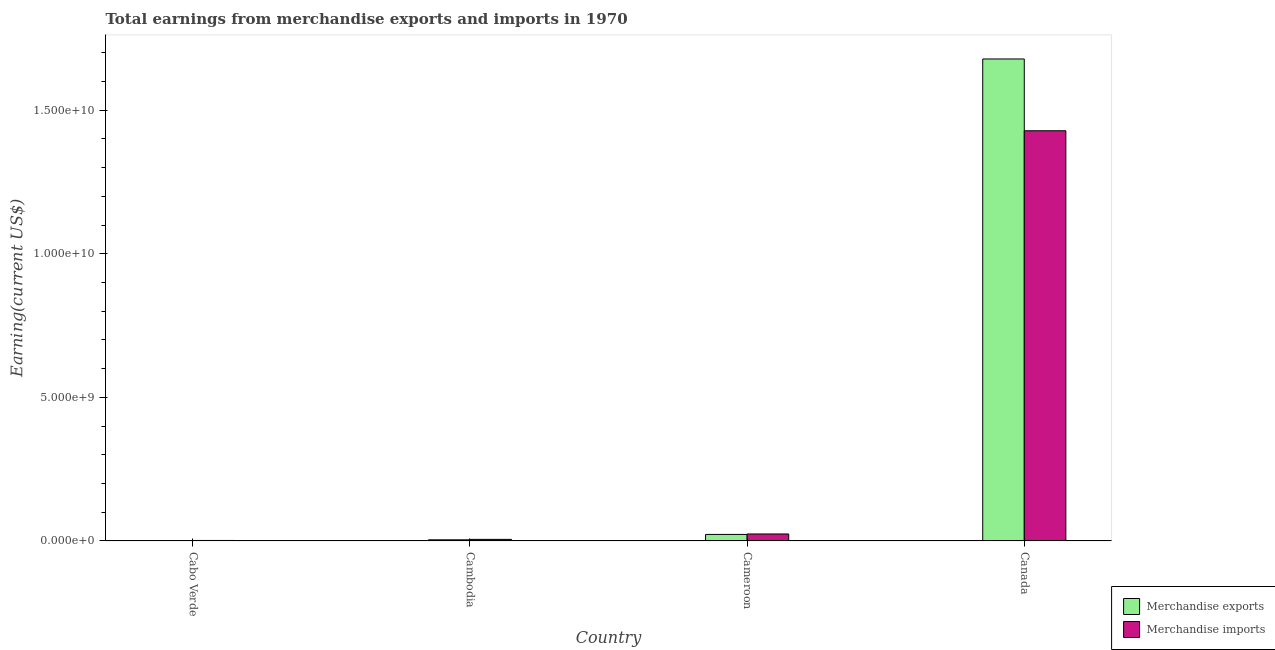How many different coloured bars are there?
Provide a succinct answer. 2. How many groups of bars are there?
Ensure brevity in your answer.  4. Are the number of bars on each tick of the X-axis equal?
Give a very brief answer. Yes. How many bars are there on the 2nd tick from the right?
Make the answer very short. 2. What is the label of the 1st group of bars from the left?
Your answer should be very brief. Cabo Verde. What is the earnings from merchandise exports in Canada?
Make the answer very short. 1.68e+1. Across all countries, what is the maximum earnings from merchandise exports?
Ensure brevity in your answer.  1.68e+1. Across all countries, what is the minimum earnings from merchandise imports?
Your answer should be very brief. 1.63e+07. In which country was the earnings from merchandise exports maximum?
Your answer should be very brief. Canada. In which country was the earnings from merchandise imports minimum?
Make the answer very short. Cabo Verde. What is the total earnings from merchandise exports in the graph?
Give a very brief answer. 1.71e+1. What is the difference between the earnings from merchandise exports in Cabo Verde and that in Cameroon?
Give a very brief answer. -2.24e+08. What is the difference between the earnings from merchandise imports in Cambodia and the earnings from merchandise exports in Cameroon?
Your answer should be compact. -1.72e+08. What is the average earnings from merchandise imports per country?
Your answer should be compact. 3.65e+09. What is the difference between the earnings from merchandise imports and earnings from merchandise exports in Cameroon?
Your response must be concise. 1.61e+07. What is the ratio of the earnings from merchandise imports in Cambodia to that in Canada?
Offer a terse response. 0. Is the difference between the earnings from merchandise exports in Cabo Verde and Canada greater than the difference between the earnings from merchandise imports in Cabo Verde and Canada?
Keep it short and to the point. No. What is the difference between the highest and the second highest earnings from merchandise imports?
Your response must be concise. 1.40e+1. What is the difference between the highest and the lowest earnings from merchandise exports?
Your answer should be compact. 1.68e+1. In how many countries, is the earnings from merchandise exports greater than the average earnings from merchandise exports taken over all countries?
Make the answer very short. 1. Is the sum of the earnings from merchandise imports in Cambodia and Canada greater than the maximum earnings from merchandise exports across all countries?
Offer a very short reply. No. What does the 1st bar from the right in Cambodia represents?
Your answer should be compact. Merchandise imports. Are all the bars in the graph horizontal?
Offer a terse response. No. How many countries are there in the graph?
Provide a short and direct response. 4. Are the values on the major ticks of Y-axis written in scientific E-notation?
Your response must be concise. Yes. Does the graph contain any zero values?
Offer a very short reply. No. How are the legend labels stacked?
Make the answer very short. Vertical. What is the title of the graph?
Make the answer very short. Total earnings from merchandise exports and imports in 1970. Does "Working only" appear as one of the legend labels in the graph?
Your answer should be very brief. No. What is the label or title of the X-axis?
Your answer should be compact. Country. What is the label or title of the Y-axis?
Give a very brief answer. Earning(current US$). What is the Earning(current US$) of Merchandise exports in Cabo Verde?
Ensure brevity in your answer.  1.66e+06. What is the Earning(current US$) in Merchandise imports in Cabo Verde?
Offer a very short reply. 1.63e+07. What is the Earning(current US$) of Merchandise exports in Cambodia?
Offer a very short reply. 3.90e+07. What is the Earning(current US$) in Merchandise imports in Cambodia?
Provide a short and direct response. 5.40e+07. What is the Earning(current US$) of Merchandise exports in Cameroon?
Give a very brief answer. 2.26e+08. What is the Earning(current US$) in Merchandise imports in Cameroon?
Your answer should be compact. 2.42e+08. What is the Earning(current US$) of Merchandise exports in Canada?
Offer a terse response. 1.68e+1. What is the Earning(current US$) in Merchandise imports in Canada?
Give a very brief answer. 1.43e+1. Across all countries, what is the maximum Earning(current US$) of Merchandise exports?
Ensure brevity in your answer.  1.68e+1. Across all countries, what is the maximum Earning(current US$) in Merchandise imports?
Your answer should be compact. 1.43e+1. Across all countries, what is the minimum Earning(current US$) in Merchandise exports?
Your answer should be very brief. 1.66e+06. Across all countries, what is the minimum Earning(current US$) of Merchandise imports?
Make the answer very short. 1.63e+07. What is the total Earning(current US$) of Merchandise exports in the graph?
Your answer should be very brief. 1.71e+1. What is the total Earning(current US$) of Merchandise imports in the graph?
Keep it short and to the point. 1.46e+1. What is the difference between the Earning(current US$) in Merchandise exports in Cabo Verde and that in Cambodia?
Your answer should be compact. -3.73e+07. What is the difference between the Earning(current US$) in Merchandise imports in Cabo Verde and that in Cambodia?
Give a very brief answer. -3.77e+07. What is the difference between the Earning(current US$) in Merchandise exports in Cabo Verde and that in Cameroon?
Provide a short and direct response. -2.24e+08. What is the difference between the Earning(current US$) of Merchandise imports in Cabo Verde and that in Cameroon?
Offer a terse response. -2.26e+08. What is the difference between the Earning(current US$) in Merchandise exports in Cabo Verde and that in Canada?
Your answer should be very brief. -1.68e+1. What is the difference between the Earning(current US$) in Merchandise imports in Cabo Verde and that in Canada?
Your answer should be very brief. -1.43e+1. What is the difference between the Earning(current US$) in Merchandise exports in Cambodia and that in Cameroon?
Ensure brevity in your answer.  -1.87e+08. What is the difference between the Earning(current US$) of Merchandise imports in Cambodia and that in Cameroon?
Your answer should be very brief. -1.88e+08. What is the difference between the Earning(current US$) of Merchandise exports in Cambodia and that in Canada?
Provide a succinct answer. -1.67e+1. What is the difference between the Earning(current US$) of Merchandise imports in Cambodia and that in Canada?
Offer a very short reply. -1.42e+1. What is the difference between the Earning(current US$) of Merchandise exports in Cameroon and that in Canada?
Your response must be concise. -1.66e+1. What is the difference between the Earning(current US$) in Merchandise imports in Cameroon and that in Canada?
Keep it short and to the point. -1.40e+1. What is the difference between the Earning(current US$) of Merchandise exports in Cabo Verde and the Earning(current US$) of Merchandise imports in Cambodia?
Your answer should be compact. -5.23e+07. What is the difference between the Earning(current US$) of Merchandise exports in Cabo Verde and the Earning(current US$) of Merchandise imports in Cameroon?
Ensure brevity in your answer.  -2.40e+08. What is the difference between the Earning(current US$) of Merchandise exports in Cabo Verde and the Earning(current US$) of Merchandise imports in Canada?
Give a very brief answer. -1.43e+1. What is the difference between the Earning(current US$) in Merchandise exports in Cambodia and the Earning(current US$) in Merchandise imports in Cameroon?
Make the answer very short. -2.03e+08. What is the difference between the Earning(current US$) of Merchandise exports in Cambodia and the Earning(current US$) of Merchandise imports in Canada?
Offer a very short reply. -1.42e+1. What is the difference between the Earning(current US$) in Merchandise exports in Cameroon and the Earning(current US$) in Merchandise imports in Canada?
Your response must be concise. -1.41e+1. What is the average Earning(current US$) in Merchandise exports per country?
Offer a terse response. 4.26e+09. What is the average Earning(current US$) in Merchandise imports per country?
Keep it short and to the point. 3.65e+09. What is the difference between the Earning(current US$) of Merchandise exports and Earning(current US$) of Merchandise imports in Cabo Verde?
Provide a short and direct response. -1.47e+07. What is the difference between the Earning(current US$) of Merchandise exports and Earning(current US$) of Merchandise imports in Cambodia?
Make the answer very short. -1.50e+07. What is the difference between the Earning(current US$) in Merchandise exports and Earning(current US$) in Merchandise imports in Cameroon?
Your response must be concise. -1.61e+07. What is the difference between the Earning(current US$) of Merchandise exports and Earning(current US$) of Merchandise imports in Canada?
Give a very brief answer. 2.50e+09. What is the ratio of the Earning(current US$) in Merchandise exports in Cabo Verde to that in Cambodia?
Offer a very short reply. 0.04. What is the ratio of the Earning(current US$) of Merchandise imports in Cabo Verde to that in Cambodia?
Give a very brief answer. 0.3. What is the ratio of the Earning(current US$) in Merchandise exports in Cabo Verde to that in Cameroon?
Ensure brevity in your answer.  0.01. What is the ratio of the Earning(current US$) in Merchandise imports in Cabo Verde to that in Cameroon?
Your response must be concise. 0.07. What is the ratio of the Earning(current US$) in Merchandise exports in Cabo Verde to that in Canada?
Keep it short and to the point. 0. What is the ratio of the Earning(current US$) of Merchandise imports in Cabo Verde to that in Canada?
Your response must be concise. 0. What is the ratio of the Earning(current US$) in Merchandise exports in Cambodia to that in Cameroon?
Your answer should be compact. 0.17. What is the ratio of the Earning(current US$) of Merchandise imports in Cambodia to that in Cameroon?
Provide a succinct answer. 0.22. What is the ratio of the Earning(current US$) in Merchandise exports in Cambodia to that in Canada?
Provide a succinct answer. 0. What is the ratio of the Earning(current US$) of Merchandise imports in Cambodia to that in Canada?
Your answer should be very brief. 0. What is the ratio of the Earning(current US$) in Merchandise exports in Cameroon to that in Canada?
Your answer should be compact. 0.01. What is the ratio of the Earning(current US$) in Merchandise imports in Cameroon to that in Canada?
Ensure brevity in your answer.  0.02. What is the difference between the highest and the second highest Earning(current US$) in Merchandise exports?
Offer a very short reply. 1.66e+1. What is the difference between the highest and the second highest Earning(current US$) in Merchandise imports?
Ensure brevity in your answer.  1.40e+1. What is the difference between the highest and the lowest Earning(current US$) in Merchandise exports?
Give a very brief answer. 1.68e+1. What is the difference between the highest and the lowest Earning(current US$) of Merchandise imports?
Your answer should be very brief. 1.43e+1. 